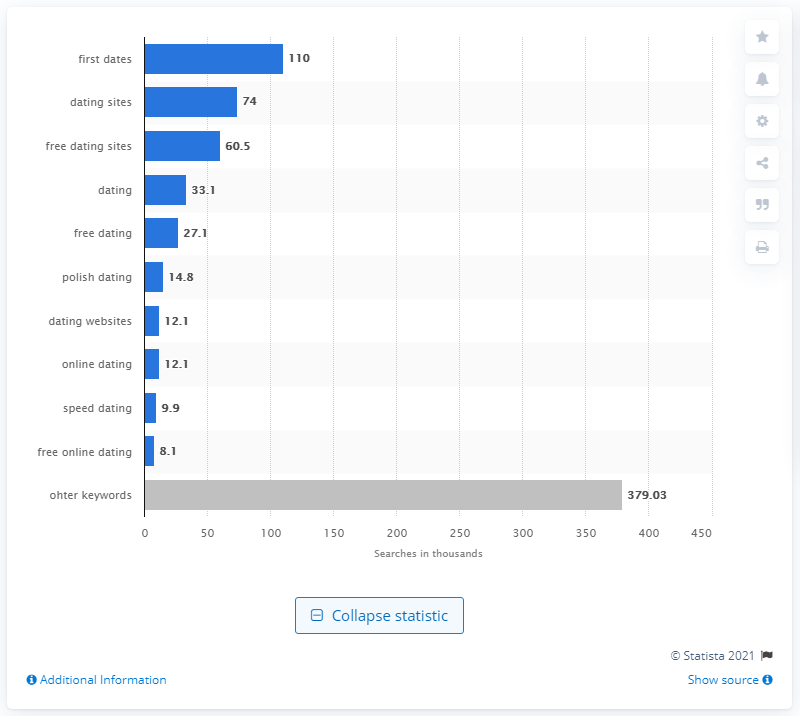Mention a couple of crucial points in this snapshot. The most sought-after search term on Google UK in February 2016 was 'first dates'. 